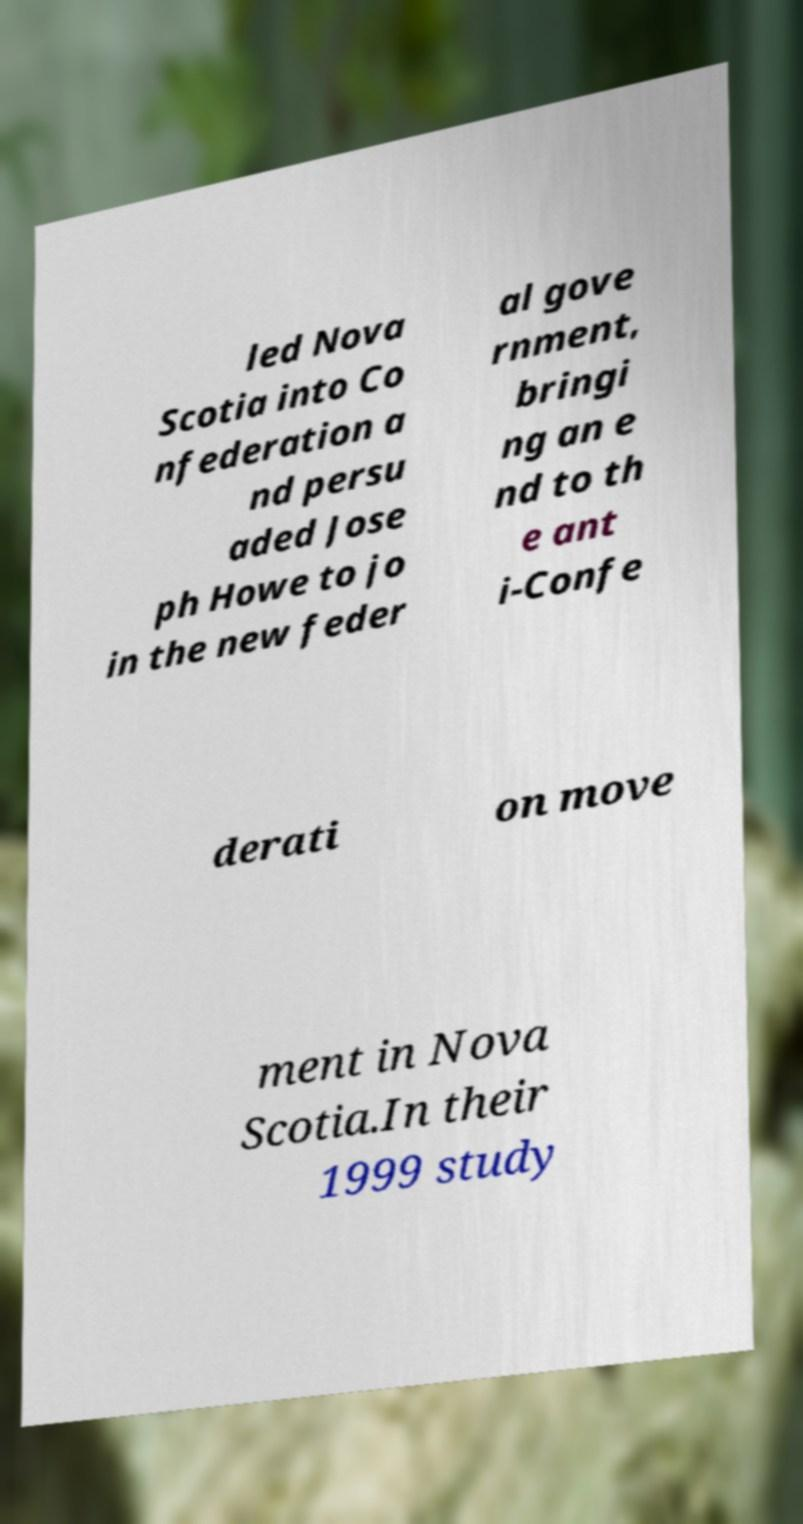There's text embedded in this image that I need extracted. Can you transcribe it verbatim? led Nova Scotia into Co nfederation a nd persu aded Jose ph Howe to jo in the new feder al gove rnment, bringi ng an e nd to th e ant i-Confe derati on move ment in Nova Scotia.In their 1999 study 